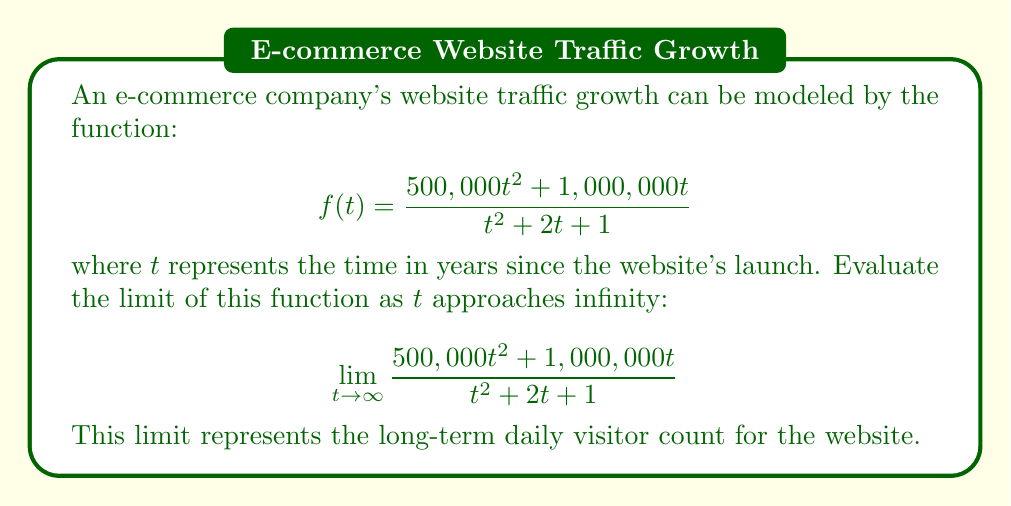Solve this math problem. To evaluate this limit, we'll use the following steps:

1) First, observe that both the numerator and denominator are polynomial functions. In such cases, the limit as $t$ approaches infinity is determined by the terms with the highest degree.

2) In both the numerator and denominator, the highest degree term is $t^2$. We can factor this out:

   $$\lim_{t \to \infty} \frac{t^2(500,000 + \frac{1,000,000}{t})}{t^2(1 + \frac{2}{t} + \frac{1}{t^2})}$$

3) The $t^2$ terms cancel out:

   $$\lim_{t \to \infty} \frac{500,000 + \frac{1,000,000}{t}}{1 + \frac{2}{t} + \frac{1}{t^2}}$$

4) As $t$ approaches infinity, $\frac{1}{t}$ and $\frac{1}{t^2}$ approach 0:

   $$\lim_{t \to \infty} \frac{500,000 + 0}{1 + 0 + 0} = \frac{500,000}{1} = 500,000$$

Therefore, the long-term daily visitor count for the website approaches 500,000.
Answer: 500,000 